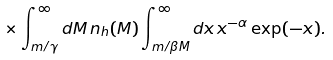Convert formula to latex. <formula><loc_0><loc_0><loc_500><loc_500>\times \int _ { m / \gamma } ^ { \infty } d M \, n _ { h } ( M ) \int _ { m / \beta M } ^ { \infty } d x \, x ^ { - \alpha } \exp ( - x ) .</formula> 